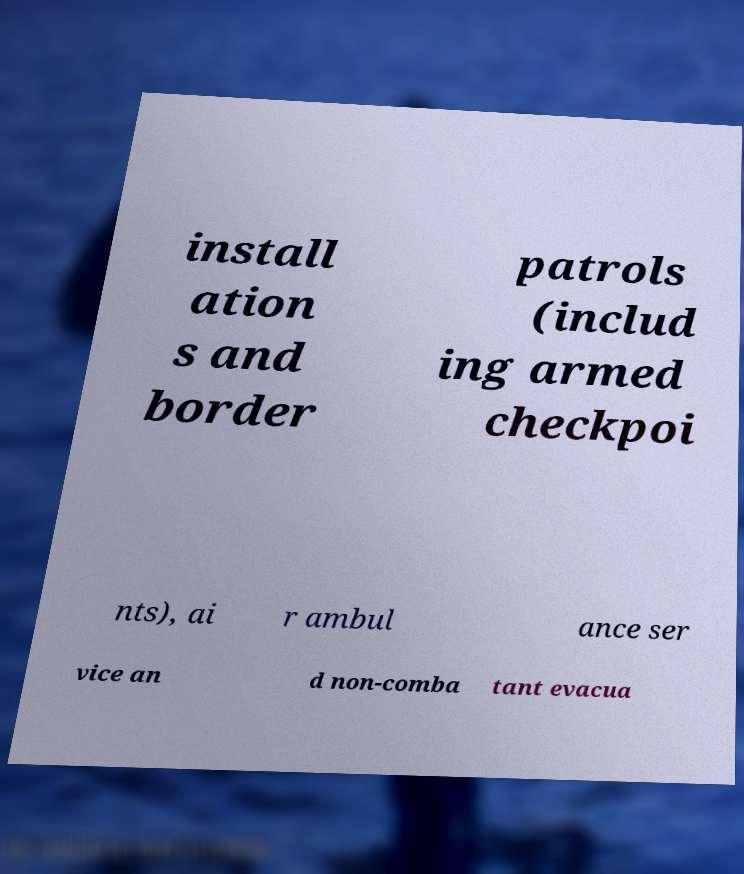Please identify and transcribe the text found in this image. install ation s and border patrols (includ ing armed checkpoi nts), ai r ambul ance ser vice an d non-comba tant evacua 